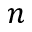Convert formula to latex. <formula><loc_0><loc_0><loc_500><loc_500>n</formula> 